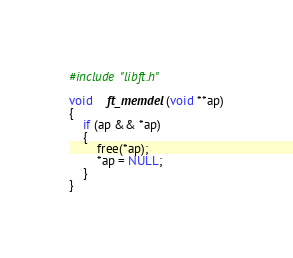<code> <loc_0><loc_0><loc_500><loc_500><_C_>#include "libft.h"

void	ft_memdel(void **ap)
{
	if (ap && *ap)
	{
		free(*ap);
		*ap = NULL;
	}
}
</code> 